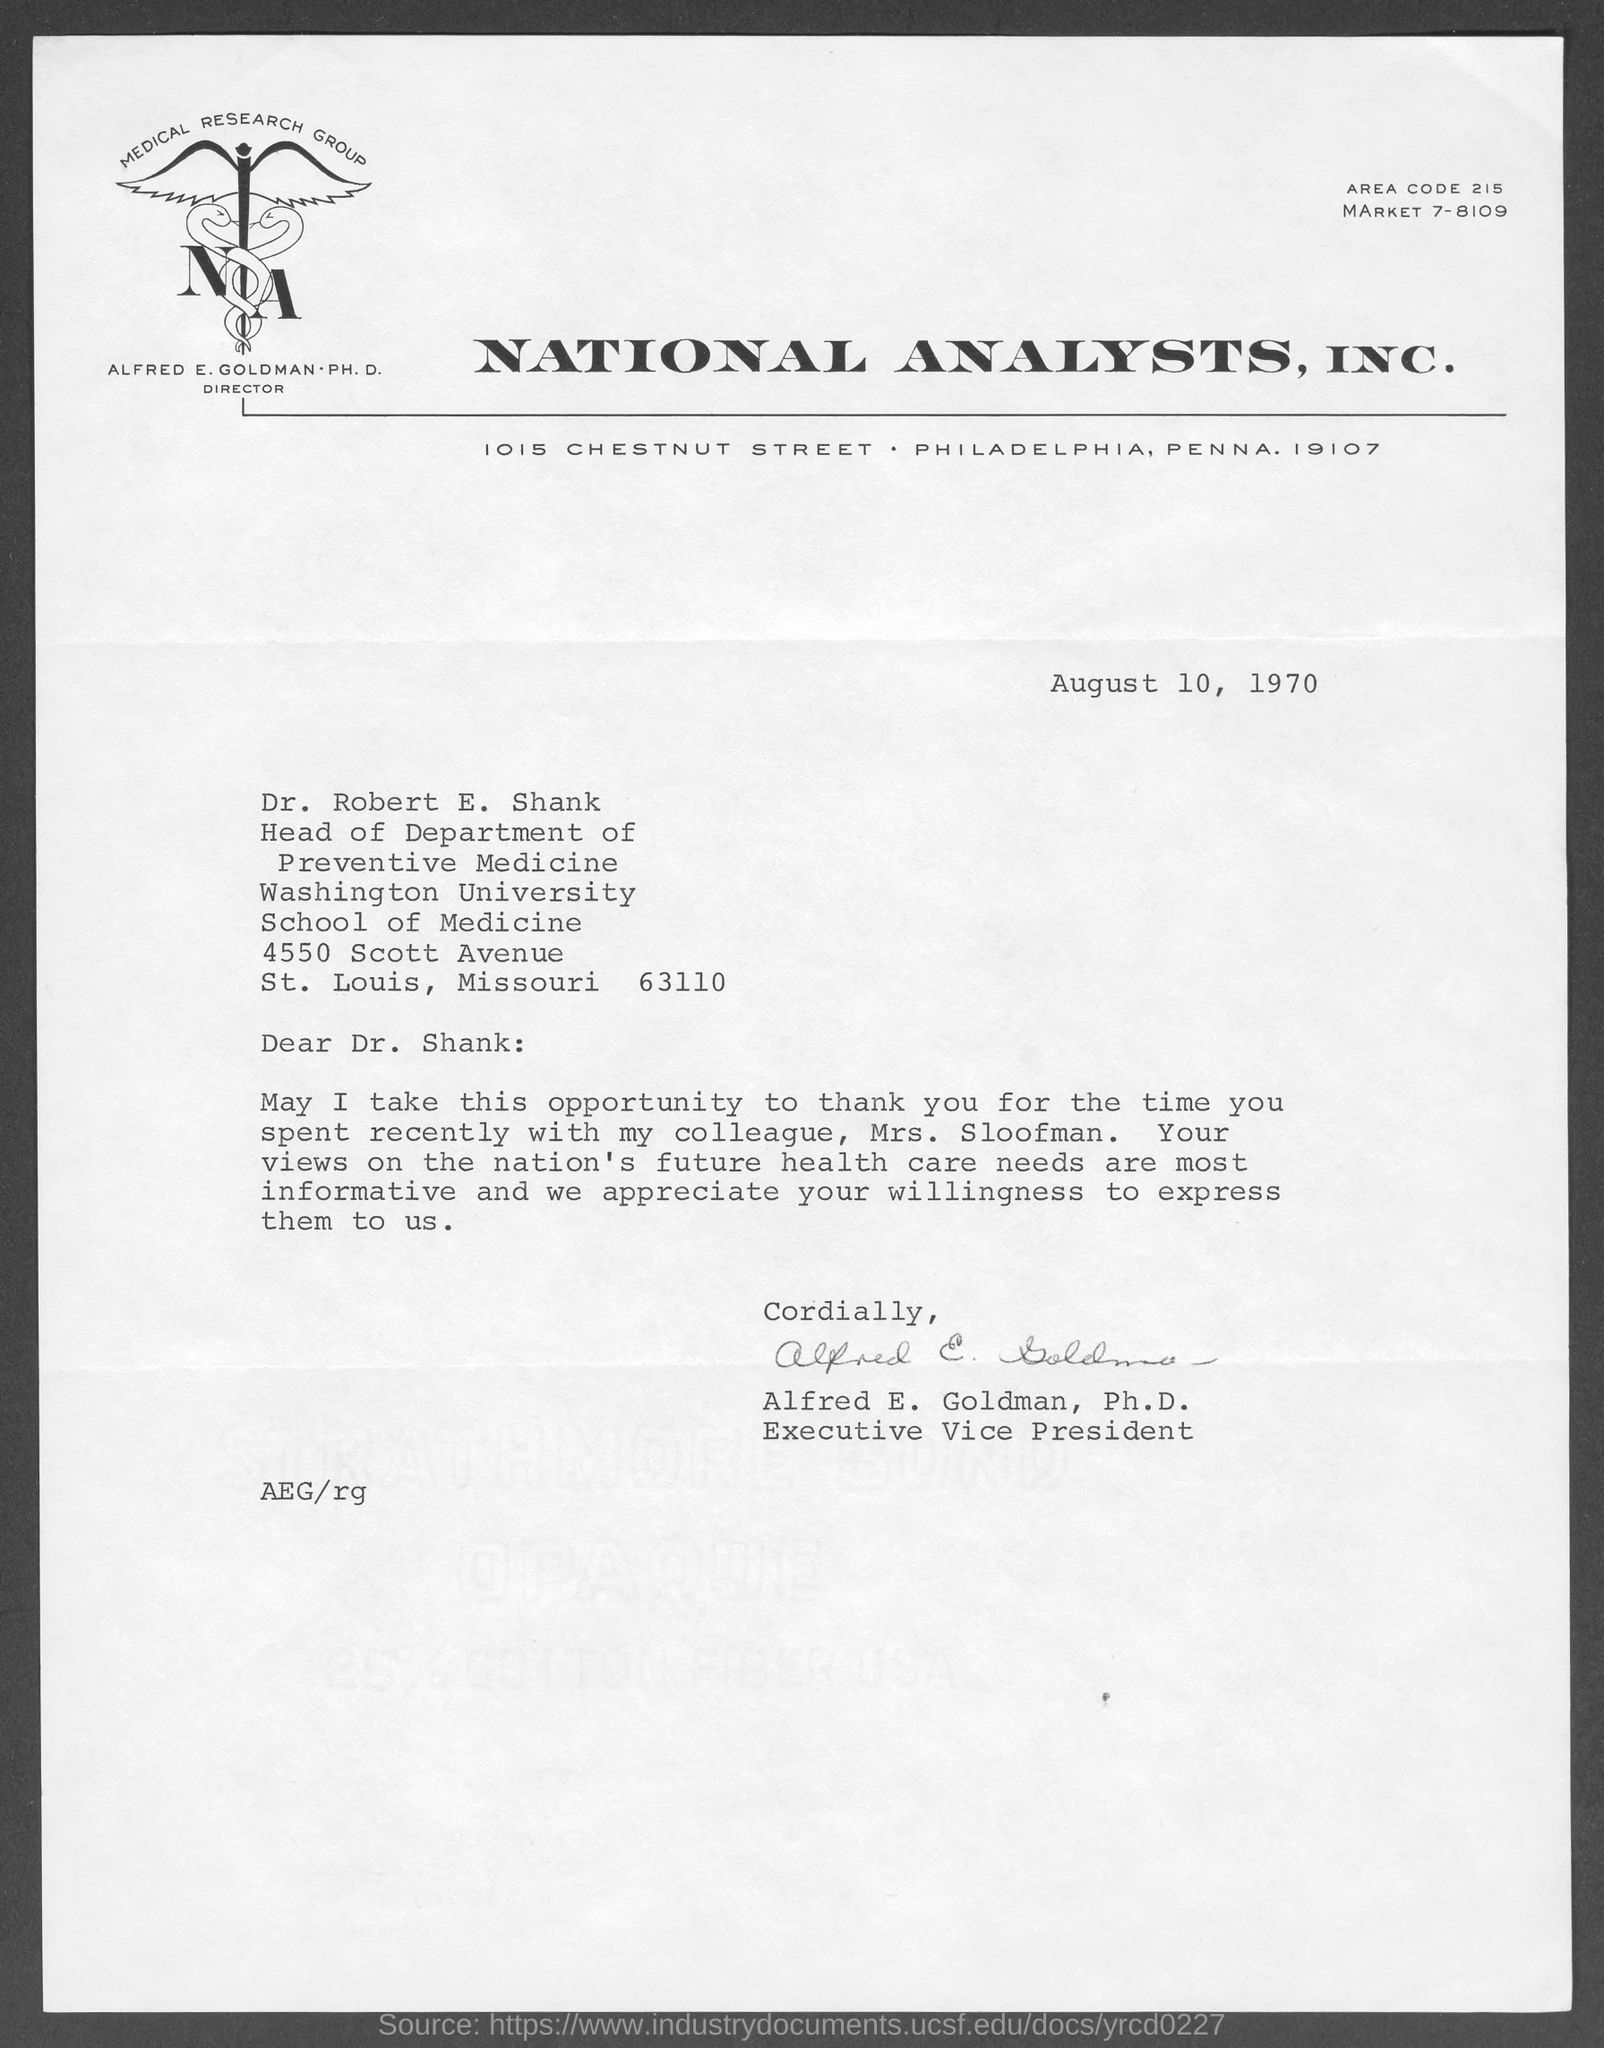List a handful of essential elements in this visual. The sender is Alfred E. Goldman, Ph.D. The document was dated August 10, 1970. The area code is 215.. National Analysts, Inc. is mentioned at the top of the page. The letter is addressed to Dr. Shank. 